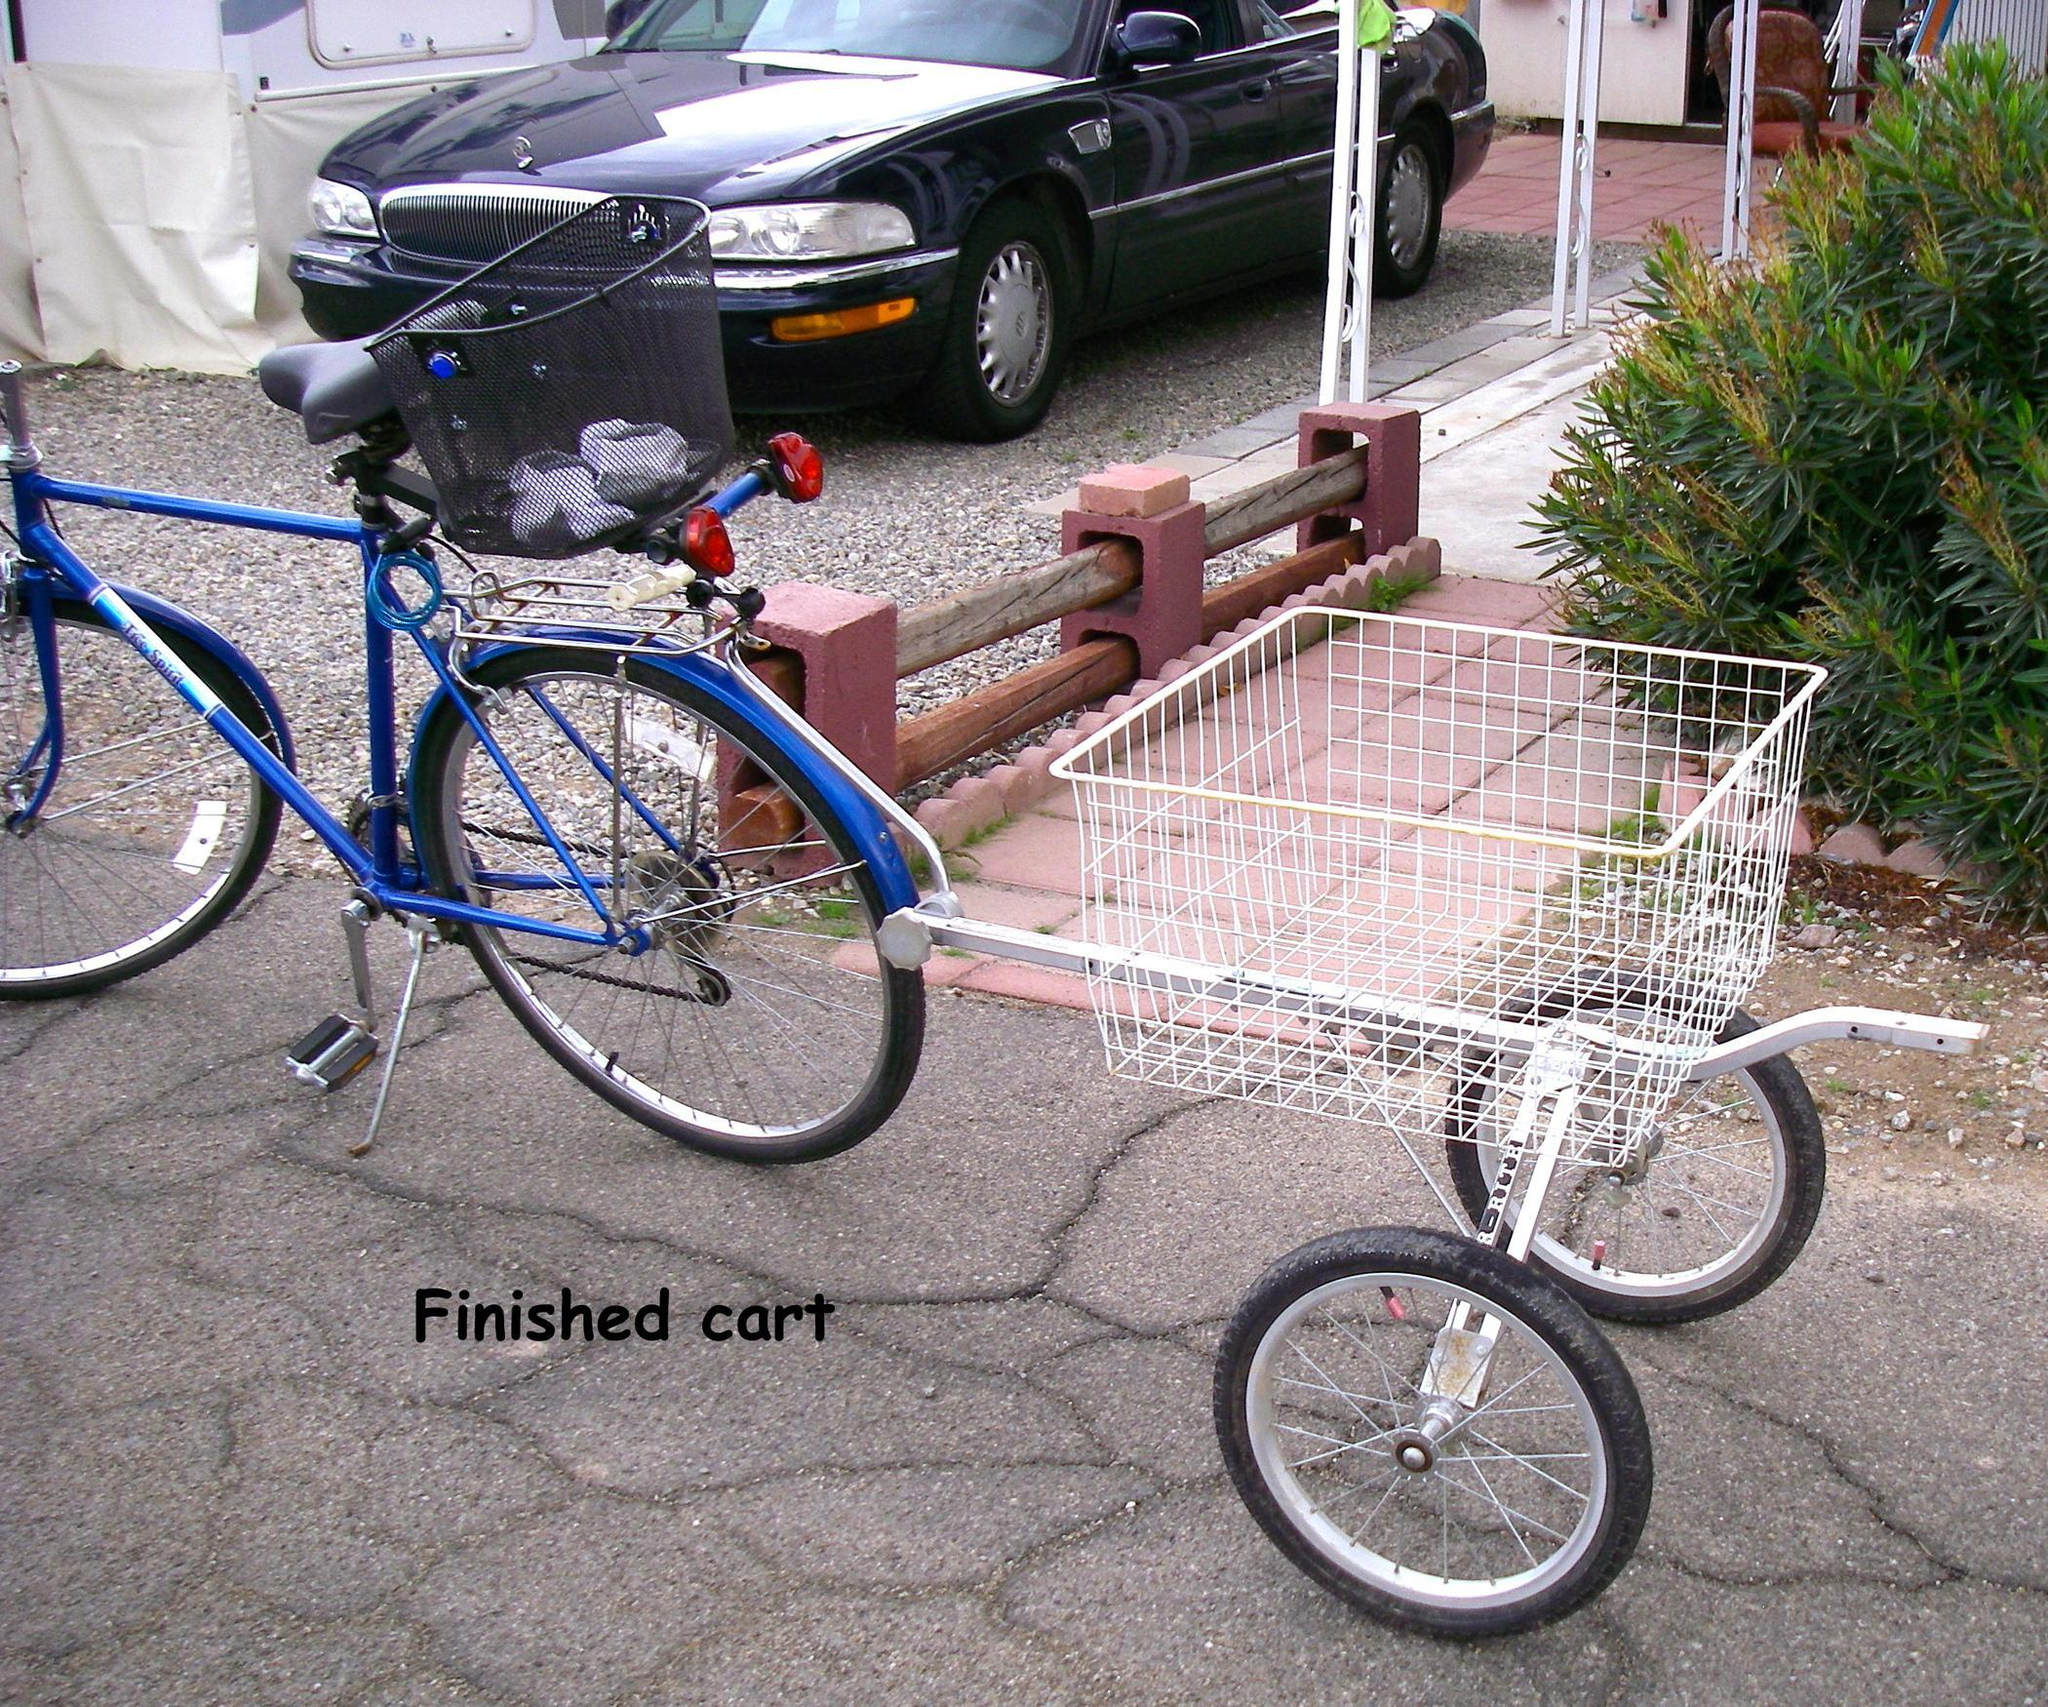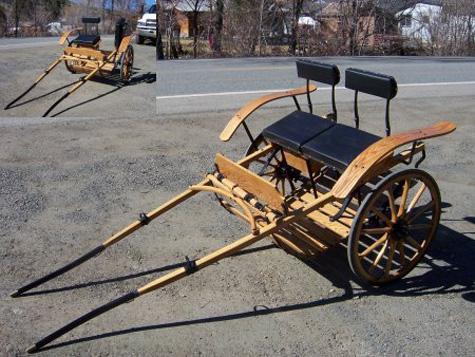The first image is the image on the left, the second image is the image on the right. Assess this claim about the two images: "At least one of the carts is rectagular and made of wood.". Correct or not? Answer yes or no. No. The first image is the image on the left, the second image is the image on the right. For the images shown, is this caption "An image shows a wooden two-wheeled cart with 'handles' tilted to the ground." true? Answer yes or no. Yes. 